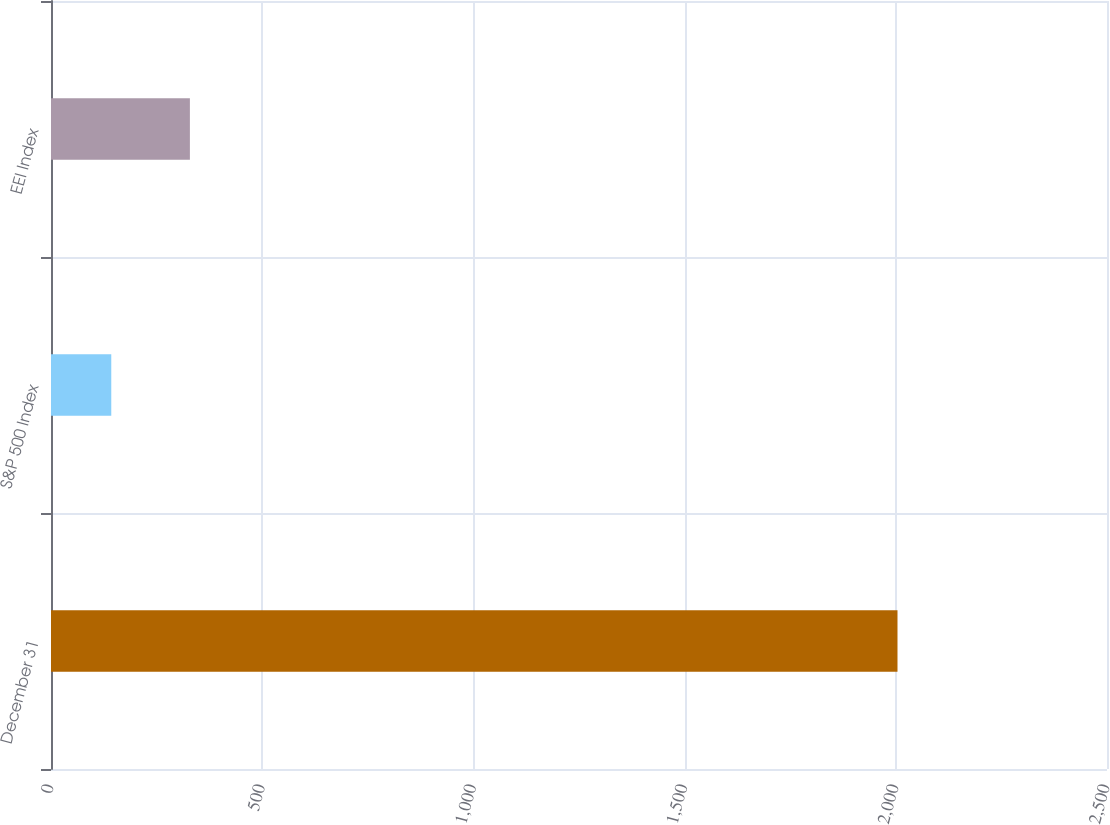<chart> <loc_0><loc_0><loc_500><loc_500><bar_chart><fcel>December 31<fcel>S&P 500 Index<fcel>EEI Index<nl><fcel>2004<fcel>142.69<fcel>328.82<nl></chart> 